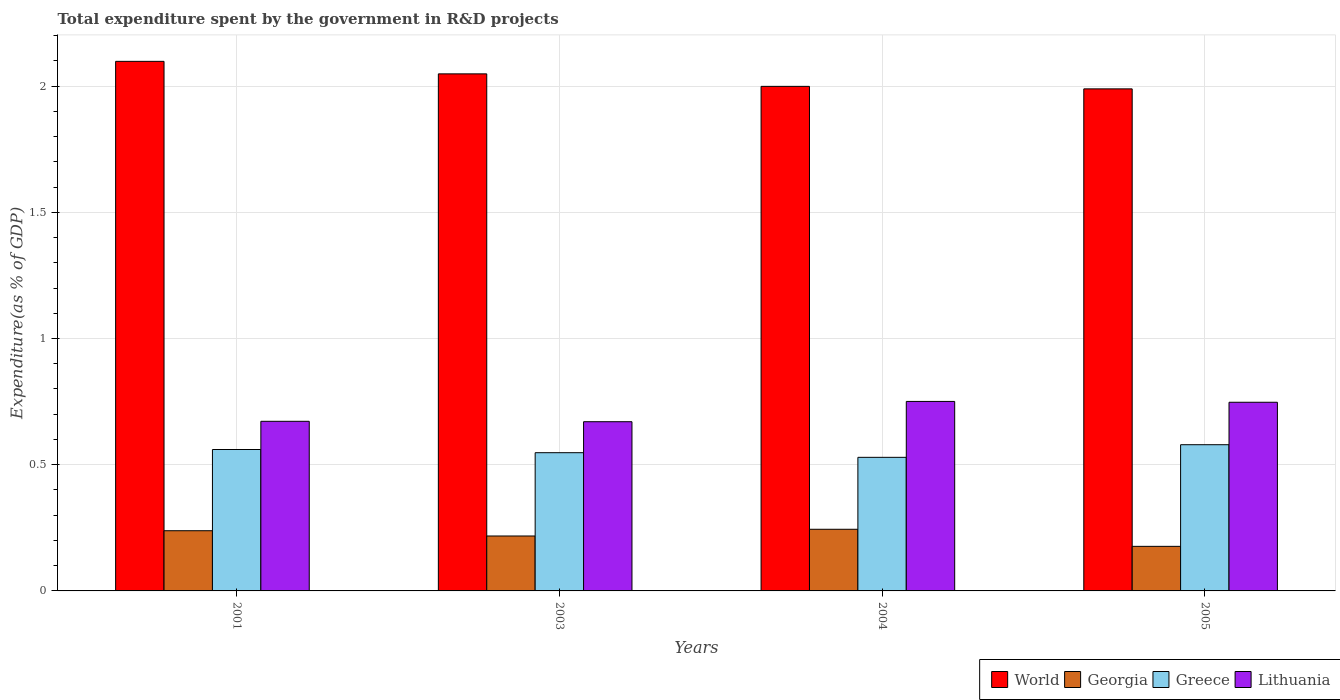How many different coloured bars are there?
Make the answer very short. 4. How many groups of bars are there?
Keep it short and to the point. 4. Are the number of bars per tick equal to the number of legend labels?
Offer a terse response. Yes. Are the number of bars on each tick of the X-axis equal?
Keep it short and to the point. Yes. How many bars are there on the 3rd tick from the left?
Your answer should be compact. 4. How many bars are there on the 2nd tick from the right?
Offer a very short reply. 4. What is the label of the 1st group of bars from the left?
Offer a terse response. 2001. What is the total expenditure spent by the government in R&D projects in Georgia in 2001?
Your answer should be very brief. 0.24. Across all years, what is the maximum total expenditure spent by the government in R&D projects in World?
Offer a very short reply. 2.1. Across all years, what is the minimum total expenditure spent by the government in R&D projects in Lithuania?
Your answer should be very brief. 0.67. What is the total total expenditure spent by the government in R&D projects in Greece in the graph?
Make the answer very short. 2.22. What is the difference between the total expenditure spent by the government in R&D projects in Greece in 2003 and that in 2005?
Provide a succinct answer. -0.03. What is the difference between the total expenditure spent by the government in R&D projects in Lithuania in 2003 and the total expenditure spent by the government in R&D projects in World in 2004?
Offer a terse response. -1.33. What is the average total expenditure spent by the government in R&D projects in World per year?
Your answer should be compact. 2.03. In the year 2001, what is the difference between the total expenditure spent by the government in R&D projects in Lithuania and total expenditure spent by the government in R&D projects in World?
Ensure brevity in your answer.  -1.43. What is the ratio of the total expenditure spent by the government in R&D projects in Georgia in 2004 to that in 2005?
Keep it short and to the point. 1.38. Is the total expenditure spent by the government in R&D projects in Georgia in 2003 less than that in 2005?
Offer a terse response. No. Is the difference between the total expenditure spent by the government in R&D projects in Lithuania in 2003 and 2005 greater than the difference between the total expenditure spent by the government in R&D projects in World in 2003 and 2005?
Provide a succinct answer. No. What is the difference between the highest and the second highest total expenditure spent by the government in R&D projects in Greece?
Give a very brief answer. 0.02. What is the difference between the highest and the lowest total expenditure spent by the government in R&D projects in Lithuania?
Offer a very short reply. 0.08. What does the 2nd bar from the left in 2005 represents?
Provide a short and direct response. Georgia. What does the 1st bar from the right in 2001 represents?
Offer a very short reply. Lithuania. Is it the case that in every year, the sum of the total expenditure spent by the government in R&D projects in World and total expenditure spent by the government in R&D projects in Greece is greater than the total expenditure spent by the government in R&D projects in Georgia?
Provide a succinct answer. Yes. How many years are there in the graph?
Give a very brief answer. 4. Where does the legend appear in the graph?
Your response must be concise. Bottom right. How many legend labels are there?
Provide a short and direct response. 4. How are the legend labels stacked?
Offer a very short reply. Horizontal. What is the title of the graph?
Give a very brief answer. Total expenditure spent by the government in R&D projects. What is the label or title of the X-axis?
Your response must be concise. Years. What is the label or title of the Y-axis?
Provide a short and direct response. Expenditure(as % of GDP). What is the Expenditure(as % of GDP) of World in 2001?
Keep it short and to the point. 2.1. What is the Expenditure(as % of GDP) in Georgia in 2001?
Provide a succinct answer. 0.24. What is the Expenditure(as % of GDP) of Greece in 2001?
Your answer should be very brief. 0.56. What is the Expenditure(as % of GDP) of Lithuania in 2001?
Offer a very short reply. 0.67. What is the Expenditure(as % of GDP) in World in 2003?
Give a very brief answer. 2.05. What is the Expenditure(as % of GDP) of Georgia in 2003?
Your answer should be very brief. 0.22. What is the Expenditure(as % of GDP) of Greece in 2003?
Keep it short and to the point. 0.55. What is the Expenditure(as % of GDP) of Lithuania in 2003?
Ensure brevity in your answer.  0.67. What is the Expenditure(as % of GDP) of World in 2004?
Ensure brevity in your answer.  2. What is the Expenditure(as % of GDP) in Georgia in 2004?
Your answer should be compact. 0.24. What is the Expenditure(as % of GDP) in Greece in 2004?
Provide a succinct answer. 0.53. What is the Expenditure(as % of GDP) of Lithuania in 2004?
Ensure brevity in your answer.  0.75. What is the Expenditure(as % of GDP) of World in 2005?
Provide a short and direct response. 1.99. What is the Expenditure(as % of GDP) in Georgia in 2005?
Offer a terse response. 0.18. What is the Expenditure(as % of GDP) in Greece in 2005?
Make the answer very short. 0.58. What is the Expenditure(as % of GDP) in Lithuania in 2005?
Ensure brevity in your answer.  0.75. Across all years, what is the maximum Expenditure(as % of GDP) of World?
Your answer should be very brief. 2.1. Across all years, what is the maximum Expenditure(as % of GDP) in Georgia?
Ensure brevity in your answer.  0.24. Across all years, what is the maximum Expenditure(as % of GDP) of Greece?
Provide a short and direct response. 0.58. Across all years, what is the maximum Expenditure(as % of GDP) in Lithuania?
Your answer should be compact. 0.75. Across all years, what is the minimum Expenditure(as % of GDP) in World?
Your answer should be compact. 1.99. Across all years, what is the minimum Expenditure(as % of GDP) in Georgia?
Make the answer very short. 0.18. Across all years, what is the minimum Expenditure(as % of GDP) in Greece?
Offer a terse response. 0.53. Across all years, what is the minimum Expenditure(as % of GDP) of Lithuania?
Give a very brief answer. 0.67. What is the total Expenditure(as % of GDP) in World in the graph?
Make the answer very short. 8.13. What is the total Expenditure(as % of GDP) of Georgia in the graph?
Provide a short and direct response. 0.88. What is the total Expenditure(as % of GDP) of Greece in the graph?
Keep it short and to the point. 2.22. What is the total Expenditure(as % of GDP) in Lithuania in the graph?
Offer a very short reply. 2.84. What is the difference between the Expenditure(as % of GDP) of World in 2001 and that in 2003?
Your response must be concise. 0.05. What is the difference between the Expenditure(as % of GDP) in Georgia in 2001 and that in 2003?
Provide a succinct answer. 0.02. What is the difference between the Expenditure(as % of GDP) of Greece in 2001 and that in 2003?
Offer a terse response. 0.01. What is the difference between the Expenditure(as % of GDP) in Lithuania in 2001 and that in 2003?
Keep it short and to the point. 0. What is the difference between the Expenditure(as % of GDP) in World in 2001 and that in 2004?
Offer a terse response. 0.1. What is the difference between the Expenditure(as % of GDP) of Georgia in 2001 and that in 2004?
Provide a short and direct response. -0.01. What is the difference between the Expenditure(as % of GDP) in Greece in 2001 and that in 2004?
Your answer should be compact. 0.03. What is the difference between the Expenditure(as % of GDP) in Lithuania in 2001 and that in 2004?
Provide a short and direct response. -0.08. What is the difference between the Expenditure(as % of GDP) in World in 2001 and that in 2005?
Provide a short and direct response. 0.11. What is the difference between the Expenditure(as % of GDP) of Georgia in 2001 and that in 2005?
Give a very brief answer. 0.06. What is the difference between the Expenditure(as % of GDP) of Greece in 2001 and that in 2005?
Offer a very short reply. -0.02. What is the difference between the Expenditure(as % of GDP) of Lithuania in 2001 and that in 2005?
Offer a very short reply. -0.08. What is the difference between the Expenditure(as % of GDP) in World in 2003 and that in 2004?
Keep it short and to the point. 0.05. What is the difference between the Expenditure(as % of GDP) of Georgia in 2003 and that in 2004?
Provide a short and direct response. -0.03. What is the difference between the Expenditure(as % of GDP) in Greece in 2003 and that in 2004?
Your response must be concise. 0.02. What is the difference between the Expenditure(as % of GDP) in Lithuania in 2003 and that in 2004?
Provide a succinct answer. -0.08. What is the difference between the Expenditure(as % of GDP) of World in 2003 and that in 2005?
Give a very brief answer. 0.06. What is the difference between the Expenditure(as % of GDP) in Georgia in 2003 and that in 2005?
Your answer should be compact. 0.04. What is the difference between the Expenditure(as % of GDP) in Greece in 2003 and that in 2005?
Keep it short and to the point. -0.03. What is the difference between the Expenditure(as % of GDP) in Lithuania in 2003 and that in 2005?
Ensure brevity in your answer.  -0.08. What is the difference between the Expenditure(as % of GDP) of World in 2004 and that in 2005?
Provide a short and direct response. 0.01. What is the difference between the Expenditure(as % of GDP) in Georgia in 2004 and that in 2005?
Keep it short and to the point. 0.07. What is the difference between the Expenditure(as % of GDP) in Lithuania in 2004 and that in 2005?
Offer a very short reply. 0. What is the difference between the Expenditure(as % of GDP) in World in 2001 and the Expenditure(as % of GDP) in Georgia in 2003?
Your answer should be compact. 1.88. What is the difference between the Expenditure(as % of GDP) of World in 2001 and the Expenditure(as % of GDP) of Greece in 2003?
Your answer should be very brief. 1.55. What is the difference between the Expenditure(as % of GDP) of World in 2001 and the Expenditure(as % of GDP) of Lithuania in 2003?
Ensure brevity in your answer.  1.43. What is the difference between the Expenditure(as % of GDP) in Georgia in 2001 and the Expenditure(as % of GDP) in Greece in 2003?
Make the answer very short. -0.31. What is the difference between the Expenditure(as % of GDP) in Georgia in 2001 and the Expenditure(as % of GDP) in Lithuania in 2003?
Ensure brevity in your answer.  -0.43. What is the difference between the Expenditure(as % of GDP) in Greece in 2001 and the Expenditure(as % of GDP) in Lithuania in 2003?
Offer a terse response. -0.11. What is the difference between the Expenditure(as % of GDP) of World in 2001 and the Expenditure(as % of GDP) of Georgia in 2004?
Provide a short and direct response. 1.85. What is the difference between the Expenditure(as % of GDP) in World in 2001 and the Expenditure(as % of GDP) in Greece in 2004?
Offer a very short reply. 1.57. What is the difference between the Expenditure(as % of GDP) in World in 2001 and the Expenditure(as % of GDP) in Lithuania in 2004?
Your response must be concise. 1.35. What is the difference between the Expenditure(as % of GDP) of Georgia in 2001 and the Expenditure(as % of GDP) of Greece in 2004?
Give a very brief answer. -0.29. What is the difference between the Expenditure(as % of GDP) in Georgia in 2001 and the Expenditure(as % of GDP) in Lithuania in 2004?
Make the answer very short. -0.51. What is the difference between the Expenditure(as % of GDP) in Greece in 2001 and the Expenditure(as % of GDP) in Lithuania in 2004?
Offer a very short reply. -0.19. What is the difference between the Expenditure(as % of GDP) of World in 2001 and the Expenditure(as % of GDP) of Georgia in 2005?
Keep it short and to the point. 1.92. What is the difference between the Expenditure(as % of GDP) of World in 2001 and the Expenditure(as % of GDP) of Greece in 2005?
Your answer should be compact. 1.52. What is the difference between the Expenditure(as % of GDP) in World in 2001 and the Expenditure(as % of GDP) in Lithuania in 2005?
Offer a very short reply. 1.35. What is the difference between the Expenditure(as % of GDP) of Georgia in 2001 and the Expenditure(as % of GDP) of Greece in 2005?
Your answer should be very brief. -0.34. What is the difference between the Expenditure(as % of GDP) of Georgia in 2001 and the Expenditure(as % of GDP) of Lithuania in 2005?
Provide a succinct answer. -0.51. What is the difference between the Expenditure(as % of GDP) in Greece in 2001 and the Expenditure(as % of GDP) in Lithuania in 2005?
Your answer should be compact. -0.19. What is the difference between the Expenditure(as % of GDP) in World in 2003 and the Expenditure(as % of GDP) in Georgia in 2004?
Your response must be concise. 1.8. What is the difference between the Expenditure(as % of GDP) of World in 2003 and the Expenditure(as % of GDP) of Greece in 2004?
Make the answer very short. 1.52. What is the difference between the Expenditure(as % of GDP) of World in 2003 and the Expenditure(as % of GDP) of Lithuania in 2004?
Give a very brief answer. 1.3. What is the difference between the Expenditure(as % of GDP) of Georgia in 2003 and the Expenditure(as % of GDP) of Greece in 2004?
Keep it short and to the point. -0.31. What is the difference between the Expenditure(as % of GDP) of Georgia in 2003 and the Expenditure(as % of GDP) of Lithuania in 2004?
Give a very brief answer. -0.53. What is the difference between the Expenditure(as % of GDP) of Greece in 2003 and the Expenditure(as % of GDP) of Lithuania in 2004?
Your answer should be compact. -0.2. What is the difference between the Expenditure(as % of GDP) in World in 2003 and the Expenditure(as % of GDP) in Georgia in 2005?
Your response must be concise. 1.87. What is the difference between the Expenditure(as % of GDP) of World in 2003 and the Expenditure(as % of GDP) of Greece in 2005?
Give a very brief answer. 1.47. What is the difference between the Expenditure(as % of GDP) of World in 2003 and the Expenditure(as % of GDP) of Lithuania in 2005?
Offer a very short reply. 1.3. What is the difference between the Expenditure(as % of GDP) in Georgia in 2003 and the Expenditure(as % of GDP) in Greece in 2005?
Offer a terse response. -0.36. What is the difference between the Expenditure(as % of GDP) in Georgia in 2003 and the Expenditure(as % of GDP) in Lithuania in 2005?
Provide a succinct answer. -0.53. What is the difference between the Expenditure(as % of GDP) of Greece in 2003 and the Expenditure(as % of GDP) of Lithuania in 2005?
Provide a succinct answer. -0.2. What is the difference between the Expenditure(as % of GDP) of World in 2004 and the Expenditure(as % of GDP) of Georgia in 2005?
Offer a very short reply. 1.82. What is the difference between the Expenditure(as % of GDP) in World in 2004 and the Expenditure(as % of GDP) in Greece in 2005?
Offer a very short reply. 1.42. What is the difference between the Expenditure(as % of GDP) of World in 2004 and the Expenditure(as % of GDP) of Lithuania in 2005?
Give a very brief answer. 1.25. What is the difference between the Expenditure(as % of GDP) of Georgia in 2004 and the Expenditure(as % of GDP) of Greece in 2005?
Your answer should be compact. -0.34. What is the difference between the Expenditure(as % of GDP) in Georgia in 2004 and the Expenditure(as % of GDP) in Lithuania in 2005?
Provide a short and direct response. -0.5. What is the difference between the Expenditure(as % of GDP) in Greece in 2004 and the Expenditure(as % of GDP) in Lithuania in 2005?
Make the answer very short. -0.22. What is the average Expenditure(as % of GDP) of World per year?
Your answer should be very brief. 2.03. What is the average Expenditure(as % of GDP) of Georgia per year?
Keep it short and to the point. 0.22. What is the average Expenditure(as % of GDP) of Greece per year?
Your answer should be compact. 0.55. What is the average Expenditure(as % of GDP) of Lithuania per year?
Your answer should be compact. 0.71. In the year 2001, what is the difference between the Expenditure(as % of GDP) of World and Expenditure(as % of GDP) of Georgia?
Ensure brevity in your answer.  1.86. In the year 2001, what is the difference between the Expenditure(as % of GDP) in World and Expenditure(as % of GDP) in Greece?
Your answer should be compact. 1.54. In the year 2001, what is the difference between the Expenditure(as % of GDP) of World and Expenditure(as % of GDP) of Lithuania?
Make the answer very short. 1.43. In the year 2001, what is the difference between the Expenditure(as % of GDP) of Georgia and Expenditure(as % of GDP) of Greece?
Your response must be concise. -0.32. In the year 2001, what is the difference between the Expenditure(as % of GDP) in Georgia and Expenditure(as % of GDP) in Lithuania?
Your answer should be compact. -0.43. In the year 2001, what is the difference between the Expenditure(as % of GDP) of Greece and Expenditure(as % of GDP) of Lithuania?
Offer a very short reply. -0.11. In the year 2003, what is the difference between the Expenditure(as % of GDP) in World and Expenditure(as % of GDP) in Georgia?
Offer a terse response. 1.83. In the year 2003, what is the difference between the Expenditure(as % of GDP) of World and Expenditure(as % of GDP) of Greece?
Keep it short and to the point. 1.5. In the year 2003, what is the difference between the Expenditure(as % of GDP) in World and Expenditure(as % of GDP) in Lithuania?
Offer a terse response. 1.38. In the year 2003, what is the difference between the Expenditure(as % of GDP) of Georgia and Expenditure(as % of GDP) of Greece?
Give a very brief answer. -0.33. In the year 2003, what is the difference between the Expenditure(as % of GDP) of Georgia and Expenditure(as % of GDP) of Lithuania?
Offer a very short reply. -0.45. In the year 2003, what is the difference between the Expenditure(as % of GDP) in Greece and Expenditure(as % of GDP) in Lithuania?
Your answer should be very brief. -0.12. In the year 2004, what is the difference between the Expenditure(as % of GDP) in World and Expenditure(as % of GDP) in Georgia?
Offer a terse response. 1.75. In the year 2004, what is the difference between the Expenditure(as % of GDP) of World and Expenditure(as % of GDP) of Greece?
Your response must be concise. 1.47. In the year 2004, what is the difference between the Expenditure(as % of GDP) in World and Expenditure(as % of GDP) in Lithuania?
Your response must be concise. 1.25. In the year 2004, what is the difference between the Expenditure(as % of GDP) of Georgia and Expenditure(as % of GDP) of Greece?
Ensure brevity in your answer.  -0.28. In the year 2004, what is the difference between the Expenditure(as % of GDP) of Georgia and Expenditure(as % of GDP) of Lithuania?
Offer a very short reply. -0.51. In the year 2004, what is the difference between the Expenditure(as % of GDP) of Greece and Expenditure(as % of GDP) of Lithuania?
Offer a very short reply. -0.22. In the year 2005, what is the difference between the Expenditure(as % of GDP) of World and Expenditure(as % of GDP) of Georgia?
Give a very brief answer. 1.81. In the year 2005, what is the difference between the Expenditure(as % of GDP) of World and Expenditure(as % of GDP) of Greece?
Keep it short and to the point. 1.41. In the year 2005, what is the difference between the Expenditure(as % of GDP) of World and Expenditure(as % of GDP) of Lithuania?
Offer a very short reply. 1.24. In the year 2005, what is the difference between the Expenditure(as % of GDP) of Georgia and Expenditure(as % of GDP) of Greece?
Provide a short and direct response. -0.4. In the year 2005, what is the difference between the Expenditure(as % of GDP) of Georgia and Expenditure(as % of GDP) of Lithuania?
Keep it short and to the point. -0.57. In the year 2005, what is the difference between the Expenditure(as % of GDP) in Greece and Expenditure(as % of GDP) in Lithuania?
Offer a very short reply. -0.17. What is the ratio of the Expenditure(as % of GDP) in World in 2001 to that in 2003?
Give a very brief answer. 1.02. What is the ratio of the Expenditure(as % of GDP) of Georgia in 2001 to that in 2003?
Your response must be concise. 1.1. What is the ratio of the Expenditure(as % of GDP) in Greece in 2001 to that in 2003?
Provide a succinct answer. 1.02. What is the ratio of the Expenditure(as % of GDP) in World in 2001 to that in 2004?
Your answer should be compact. 1.05. What is the ratio of the Expenditure(as % of GDP) of Georgia in 2001 to that in 2004?
Make the answer very short. 0.98. What is the ratio of the Expenditure(as % of GDP) of Greece in 2001 to that in 2004?
Provide a short and direct response. 1.06. What is the ratio of the Expenditure(as % of GDP) of Lithuania in 2001 to that in 2004?
Provide a succinct answer. 0.9. What is the ratio of the Expenditure(as % of GDP) in World in 2001 to that in 2005?
Offer a very short reply. 1.05. What is the ratio of the Expenditure(as % of GDP) of Georgia in 2001 to that in 2005?
Ensure brevity in your answer.  1.35. What is the ratio of the Expenditure(as % of GDP) in Greece in 2001 to that in 2005?
Your answer should be compact. 0.97. What is the ratio of the Expenditure(as % of GDP) of Lithuania in 2001 to that in 2005?
Give a very brief answer. 0.9. What is the ratio of the Expenditure(as % of GDP) of World in 2003 to that in 2004?
Your answer should be very brief. 1.02. What is the ratio of the Expenditure(as % of GDP) in Georgia in 2003 to that in 2004?
Your answer should be compact. 0.89. What is the ratio of the Expenditure(as % of GDP) of Greece in 2003 to that in 2004?
Give a very brief answer. 1.03. What is the ratio of the Expenditure(as % of GDP) in Lithuania in 2003 to that in 2004?
Offer a very short reply. 0.89. What is the ratio of the Expenditure(as % of GDP) of World in 2003 to that in 2005?
Ensure brevity in your answer.  1.03. What is the ratio of the Expenditure(as % of GDP) in Georgia in 2003 to that in 2005?
Make the answer very short. 1.23. What is the ratio of the Expenditure(as % of GDP) of Greece in 2003 to that in 2005?
Provide a succinct answer. 0.95. What is the ratio of the Expenditure(as % of GDP) in Lithuania in 2003 to that in 2005?
Ensure brevity in your answer.  0.9. What is the ratio of the Expenditure(as % of GDP) in Georgia in 2004 to that in 2005?
Provide a short and direct response. 1.38. What is the ratio of the Expenditure(as % of GDP) in Greece in 2004 to that in 2005?
Offer a very short reply. 0.91. What is the ratio of the Expenditure(as % of GDP) in Lithuania in 2004 to that in 2005?
Give a very brief answer. 1. What is the difference between the highest and the second highest Expenditure(as % of GDP) of World?
Provide a succinct answer. 0.05. What is the difference between the highest and the second highest Expenditure(as % of GDP) in Georgia?
Offer a terse response. 0.01. What is the difference between the highest and the second highest Expenditure(as % of GDP) of Greece?
Provide a short and direct response. 0.02. What is the difference between the highest and the second highest Expenditure(as % of GDP) of Lithuania?
Offer a terse response. 0. What is the difference between the highest and the lowest Expenditure(as % of GDP) of World?
Your answer should be very brief. 0.11. What is the difference between the highest and the lowest Expenditure(as % of GDP) of Georgia?
Give a very brief answer. 0.07. What is the difference between the highest and the lowest Expenditure(as % of GDP) of Lithuania?
Your response must be concise. 0.08. 